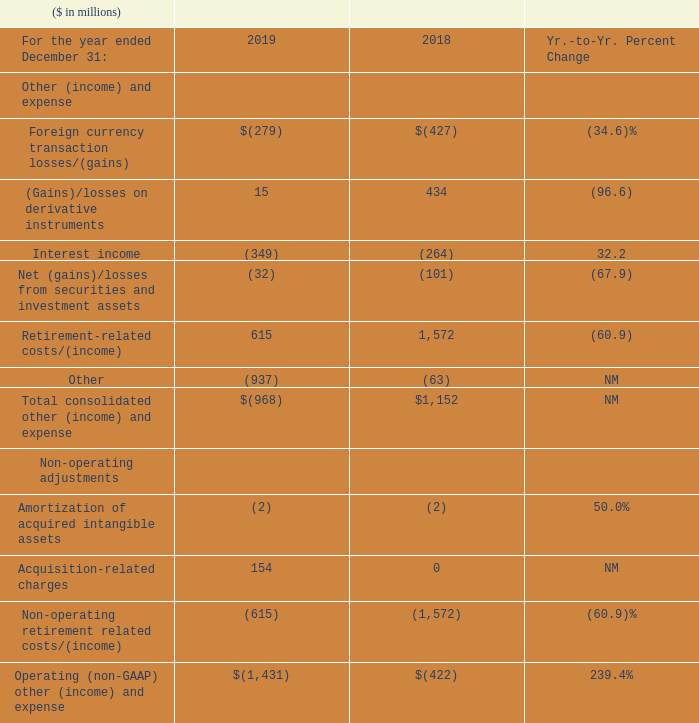Other (Income) and Expense
NM—Not meaningful
Total consolidated other (income) and expense was income of $968 million in 2019 compared to expense of $1,152 million in 2018. The year-to-year change was primarily driven by: • Lower non-operating retirement-related costs ($957 million). Refer to “Retirement-Related Plans” for additional information. • Higher gains from divestitures ($833 million) reflected in Other; and • Higher net exchange gains (including derivative instruments) ($272 million). The company’s hedging programs help mitigate currency impacts in the Consolidated Income Statement.
Operating (non-GAAP) other (income) and expense was $1,431 million of income in 2019 and increased $1,010 million compared to the prior-year period. The year-to-year change was primarily driven by the same factors excluding lower non-operating retirement-related costs.
What caused the total consolidated other (income) and expenses to decrease? The year-to-year change was primarily driven by: • lower non-operating retirement-related costs ($957 million). refer to “retirement-related plans” for additional information. • higher gains from divestitures ($833 million) reflected in other; and • higher net exchange gains (including derivative instruments) ($272 million). the company’s hedging programs help mitigate currency impacts in the consolidated income statement. What caused the Operating (non-GAAP) other (income) and expense to increase? The year-to-year change was primarily driven by the same factors excluding lower non-operating retirement-related costs. What was the total Operating (non-GAAP) other (income) and expense in 2019?
Answer scale should be: million. $(1,431). What was the increase / (decrease) in the Foreign currency transaction losses/(gains) from 2018 to 2019?
Answer scale should be: million. -279 - (-427)
Answer: 148. What is the increase / (decrease) in the interest income from 2018 to 2019?
Answer scale should be: million. -349 - (-264)
Answer: -85. What is the average Acquisition-related charges?
Answer scale should be: million. (154 + 0) / 2
Answer: 77. 